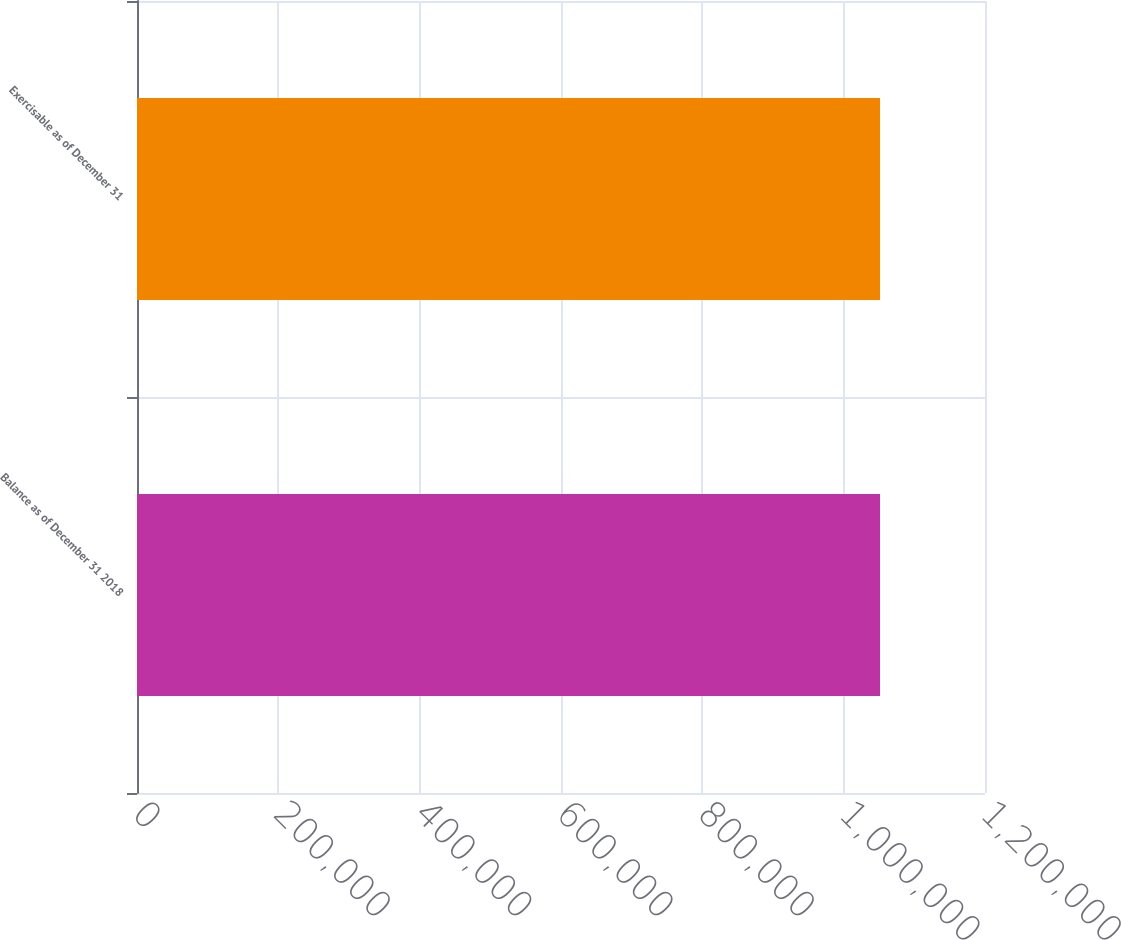<chart> <loc_0><loc_0><loc_500><loc_500><bar_chart><fcel>Balance as of December 31 2018<fcel>Exercisable as of December 31<nl><fcel>1.05149e+06<fcel>1.05149e+06<nl></chart> 